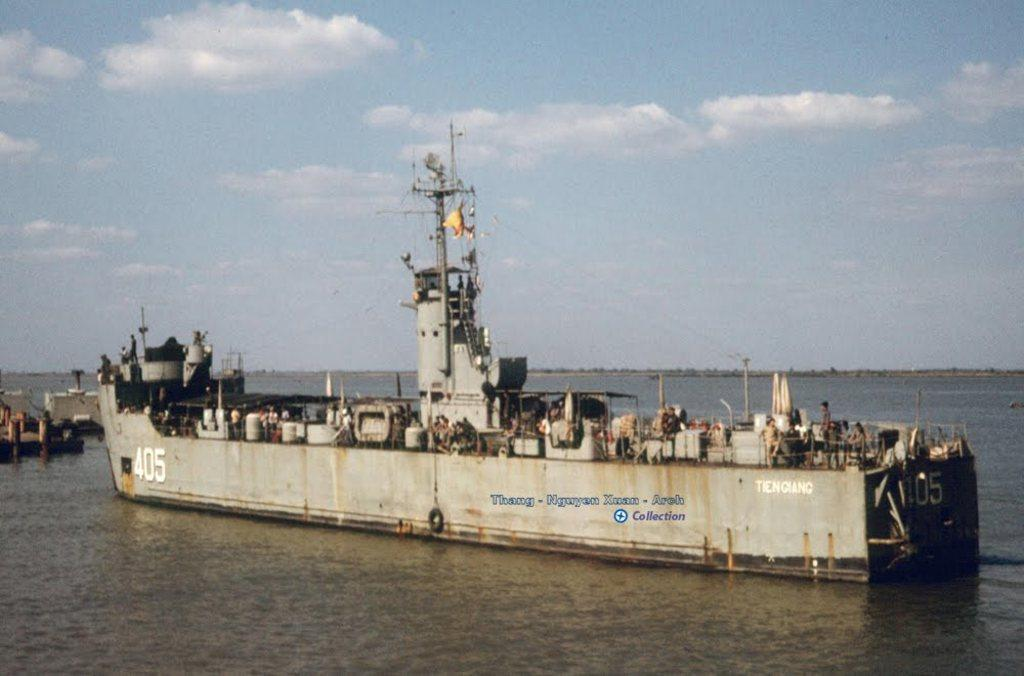What type of vehicle is in the water in the image? There is a battle cruiser in the cruiser in the water in the image. Can you describe the battle cruiser's location in the image? The battle cruiser is present in the image. What can be seen in the sky in the image? There are clouds visible in the sky. What type of plastic is being used to build the giant grape in the image? There is no plastic, giants, or grape present in the image. 